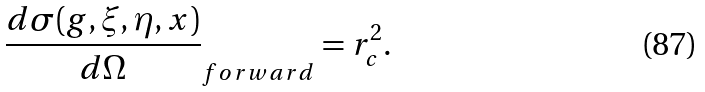<formula> <loc_0><loc_0><loc_500><loc_500>\frac { d \sigma ( g , \xi , \eta , x ) } { d \Omega } _ { f o r w a r d } = r _ { c } ^ { 2 } .</formula> 